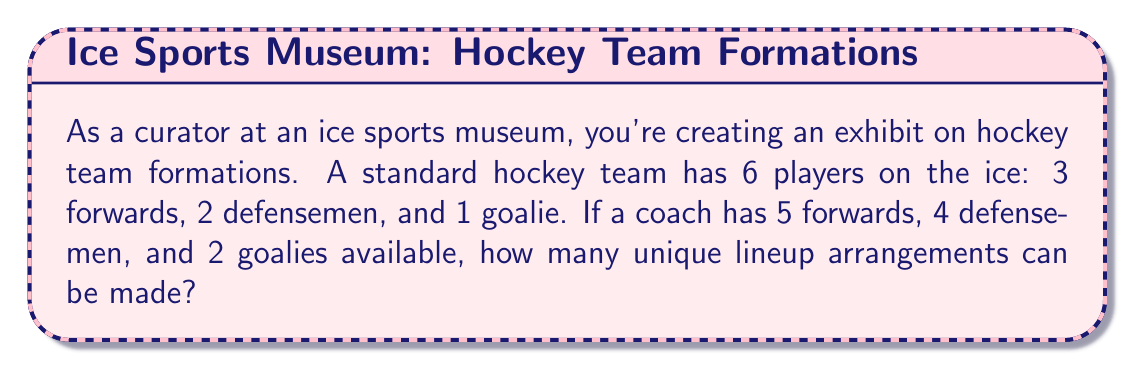What is the answer to this math problem? Let's approach this step-by-step:

1) We need to choose:
   - 3 out of 5 forwards
   - 2 out of 4 defensemen
   - 1 out of 2 goalies

2) For each position, we can use the combination formula:
   $${n \choose k} = \frac{n!}{k!(n-k)!}$$

3) For forwards: ${5 \choose 3} = \frac{5!}{3!(5-3)!} = \frac{5!}{3!2!} = 10$

4) For defensemen: ${4 \choose 2} = \frac{4!}{2!(4-2)!} = \frac{4!}{2!2!} = 6$

5) For goalies: ${2 \choose 1} = \frac{2!}{1!(2-1)!} = \frac{2!}{1!1!} = 2$

6) By the multiplication principle, the total number of unique arrangements is:

   $$ 10 \times 6 \times 2 = 120 $$

This represents all possible ways to select 3 forwards, 2 defensemen, and 1 goalie from the available players.
Answer: 120 unique lineup arrangements 